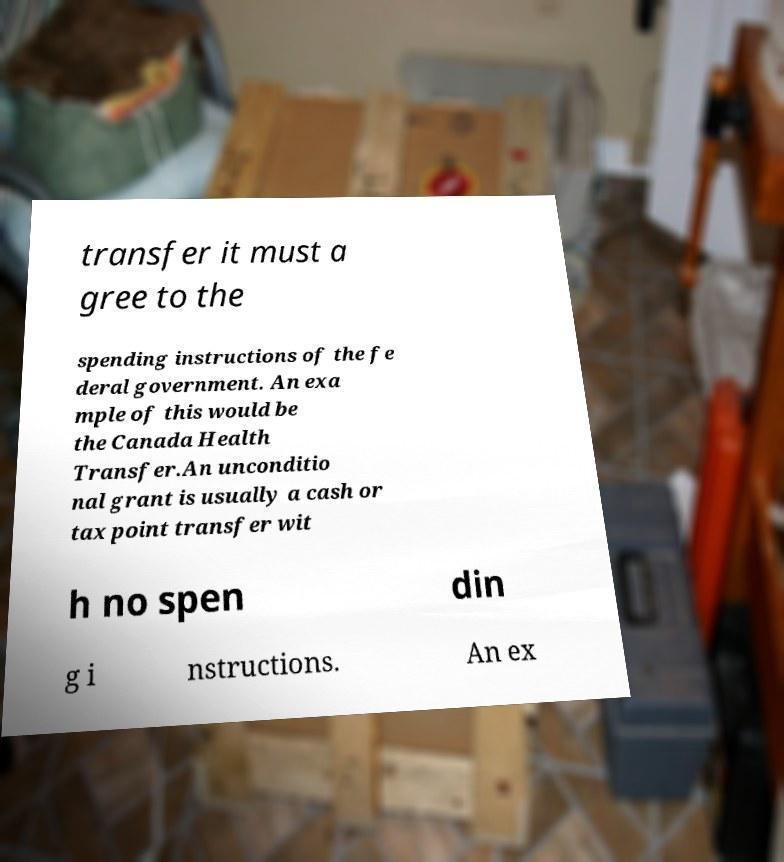For documentation purposes, I need the text within this image transcribed. Could you provide that? transfer it must a gree to the spending instructions of the fe deral government. An exa mple of this would be the Canada Health Transfer.An unconditio nal grant is usually a cash or tax point transfer wit h no spen din g i nstructions. An ex 